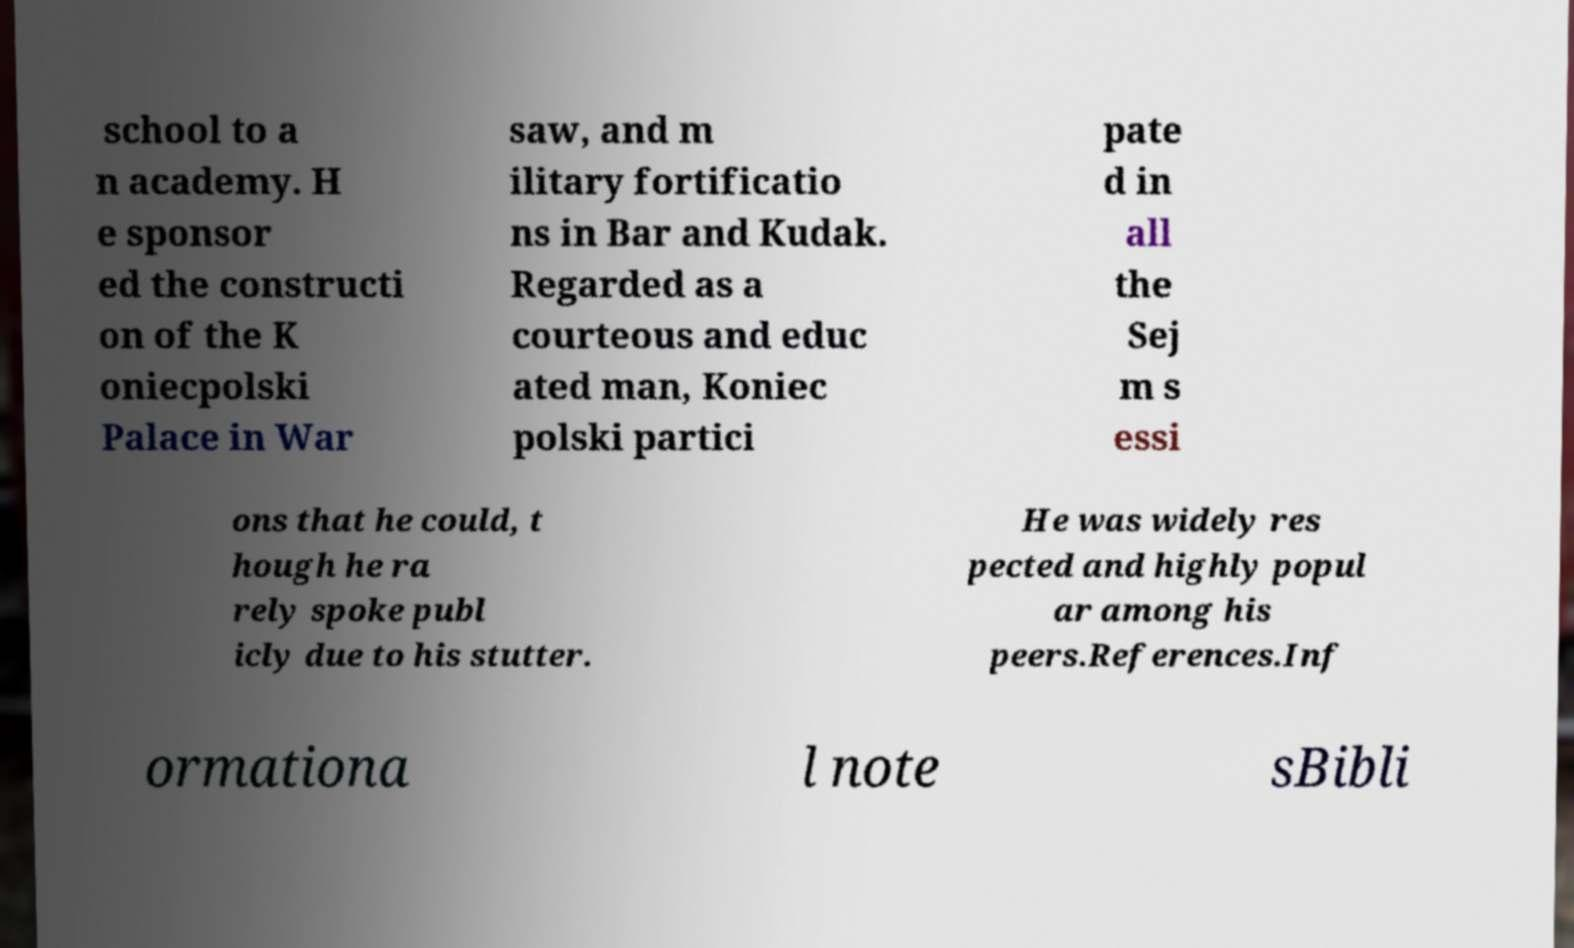Please read and relay the text visible in this image. What does it say? school to a n academy. H e sponsor ed the constructi on of the K oniecpolski Palace in War saw, and m ilitary fortificatio ns in Bar and Kudak. Regarded as a courteous and educ ated man, Koniec polski partici pate d in all the Sej m s essi ons that he could, t hough he ra rely spoke publ icly due to his stutter. He was widely res pected and highly popul ar among his peers.References.Inf ormationa l note sBibli 